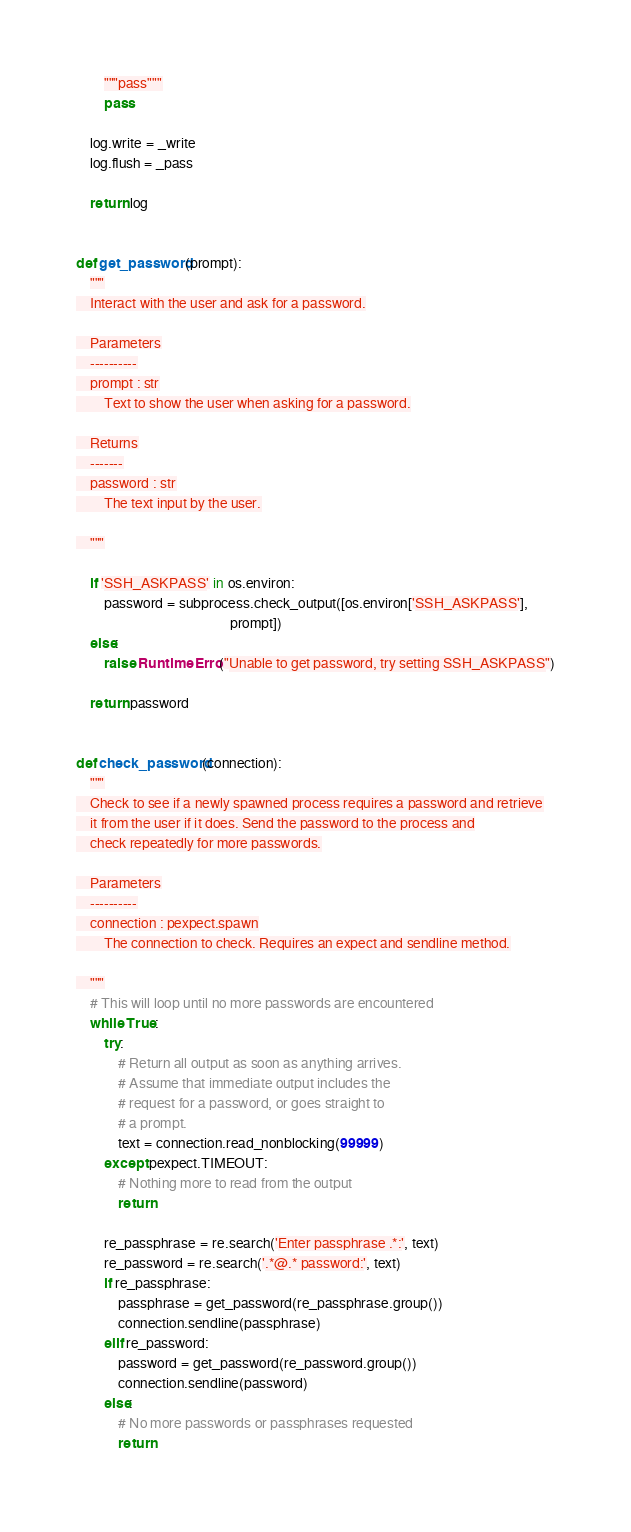Convert code to text. <code><loc_0><loc_0><loc_500><loc_500><_Python_>        """pass"""
        pass

    log.write = _write
    log.flush = _pass

    return log


def get_password(prompt):
    """
    Interact with the user and ask for a password.

    Parameters
    ----------
    prompt : str
        Text to show the user when asking for a password.

    Returns
    -------
    password : str
        The text input by the user.

    """

    if 'SSH_ASKPASS' in os.environ:
        password = subprocess.check_output([os.environ['SSH_ASKPASS'],
                                            prompt])
    else:
        raise RuntimeError("Unable to get password, try setting SSH_ASKPASS")

    return password


def check_password(connection):
    """
    Check to see if a newly spawned process requires a password and retrieve
    it from the user if it does. Send the password to the process and
    check repeatedly for more passwords.

    Parameters
    ----------
    connection : pexpect.spawn
        The connection to check. Requires an expect and sendline method.

    """
    # This will loop until no more passwords are encountered
    while True:
        try:
            # Return all output as soon as anything arrives.
            # Assume that immediate output includes the
            # request for a password, or goes straight to
            # a prompt.
            text = connection.read_nonblocking(99999)
        except pexpect.TIMEOUT:
            # Nothing more to read from the output
            return

        re_passphrase = re.search('Enter passphrase .*:', text)
        re_password = re.search('.*@.* password:', text)
        if re_passphrase:
            passphrase = get_password(re_passphrase.group())
            connection.sendline(passphrase)
        elif re_password:
            password = get_password(re_password.group())
            connection.sendline(password)
        else:
            # No more passwords or passphrases requested
            return

</code> 